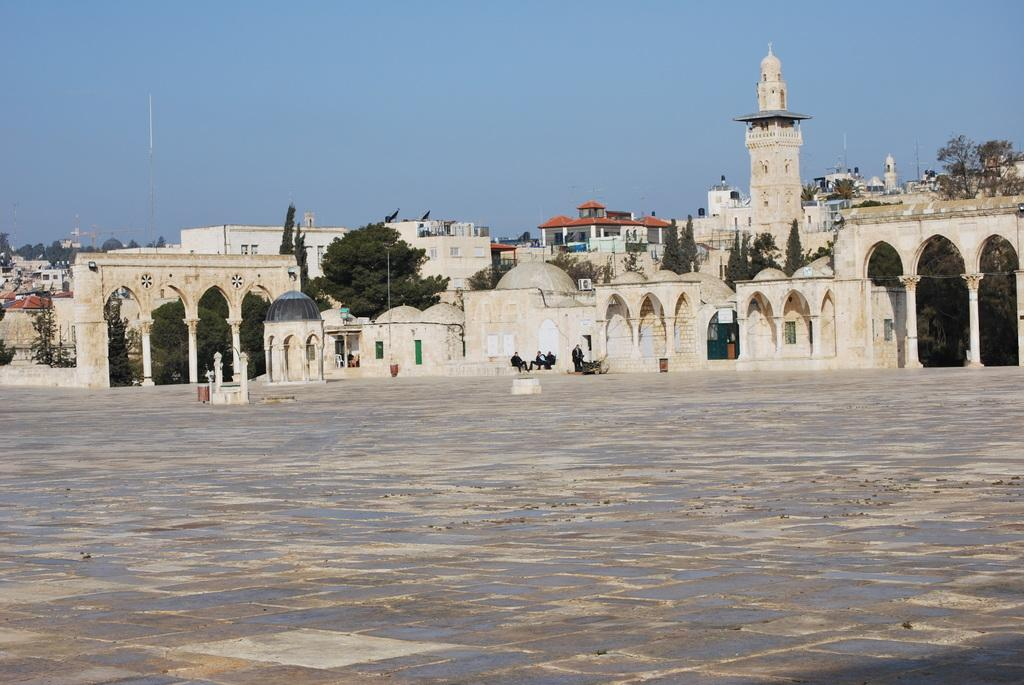What type of structures can be seen in the image? There are many buildings in the image. What other elements can be found in the image besides buildings? There are trees in the image. Can you describe the people in the image? There are people sitting in front of a building in the image. What type of appliance can be seen in the hands of the secretary in the image? There is no secretary or appliance present in the image. 